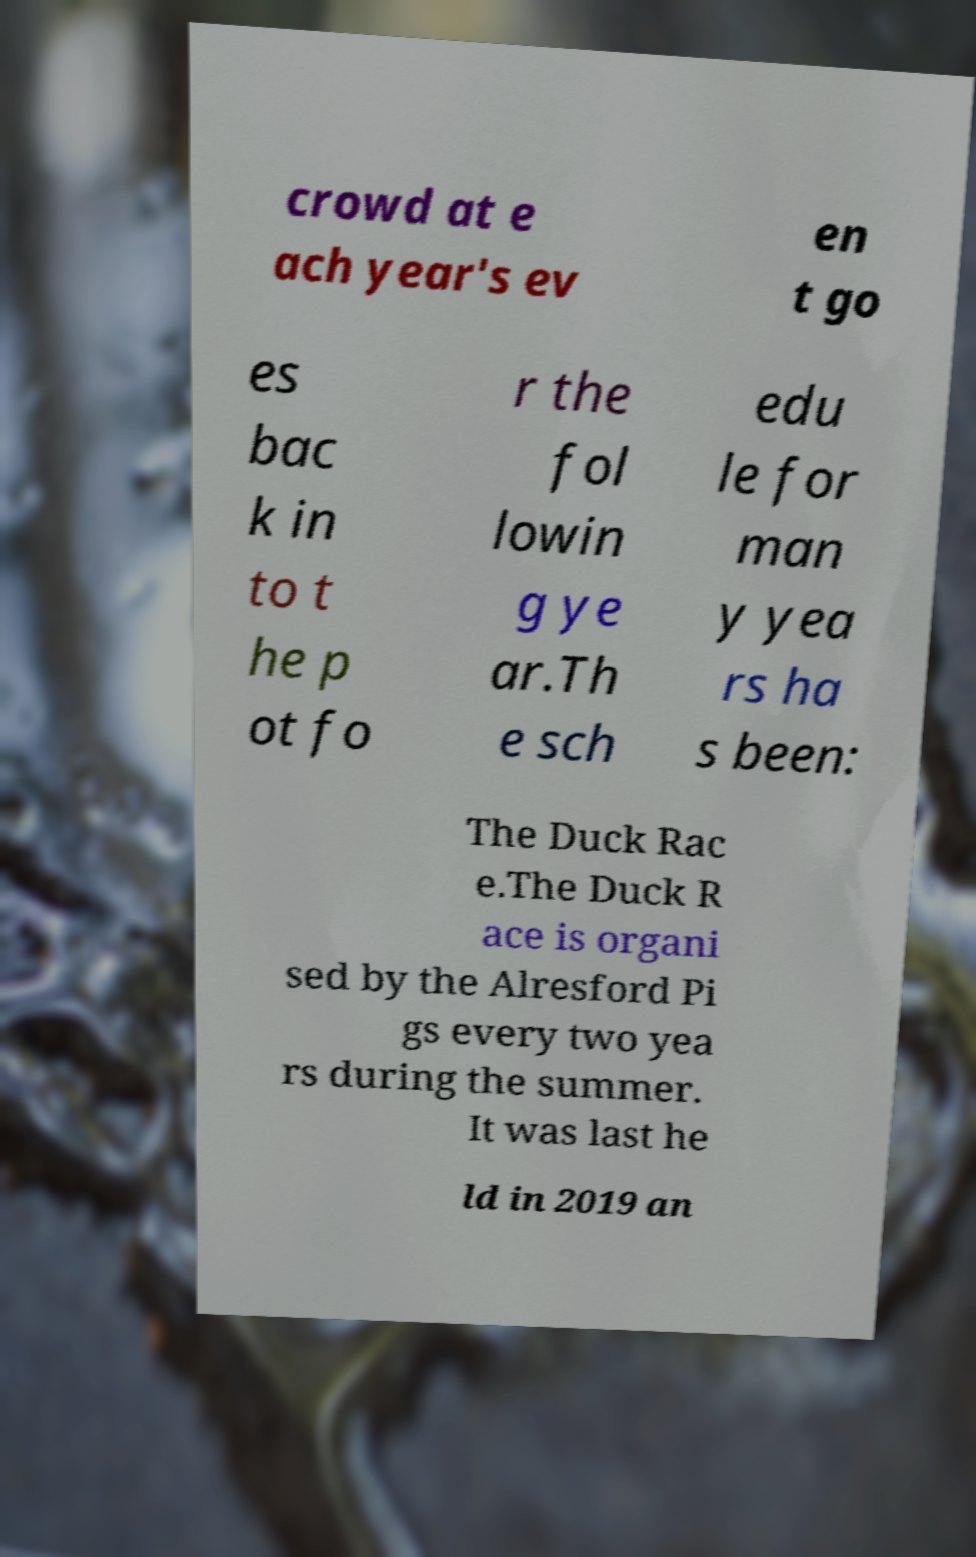Could you assist in decoding the text presented in this image and type it out clearly? crowd at e ach year's ev en t go es bac k in to t he p ot fo r the fol lowin g ye ar.Th e sch edu le for man y yea rs ha s been: The Duck Rac e.The Duck R ace is organi sed by the Alresford Pi gs every two yea rs during the summer. It was last he ld in 2019 an 